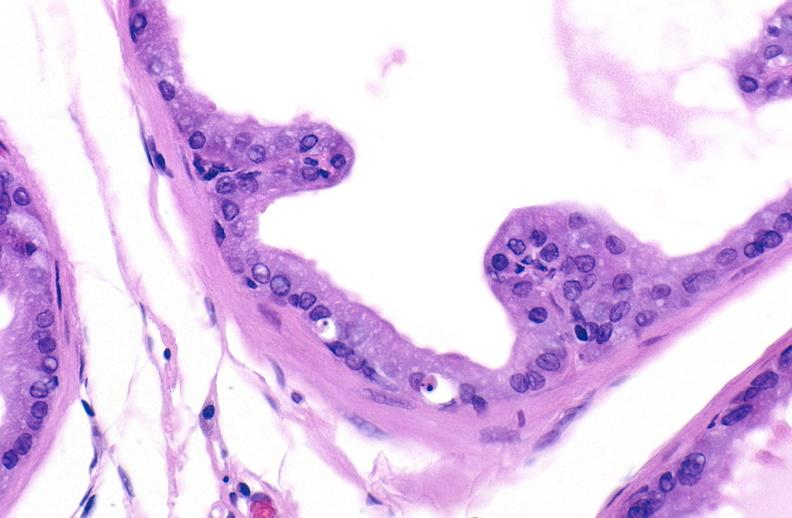when does this image show apoptosis in prostate?
Answer the question using a single word or phrase. After orchiectomy 